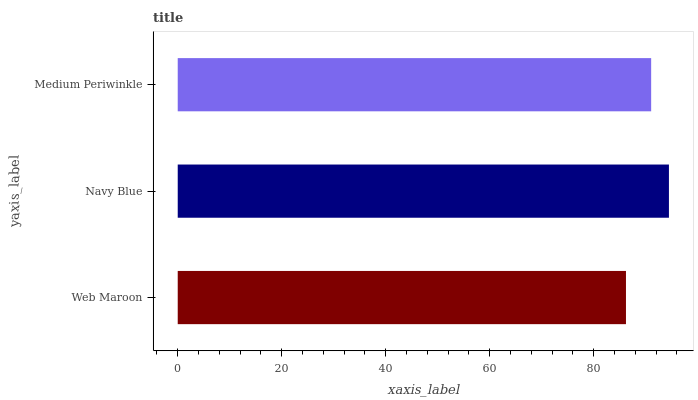Is Web Maroon the minimum?
Answer yes or no. Yes. Is Navy Blue the maximum?
Answer yes or no. Yes. Is Medium Periwinkle the minimum?
Answer yes or no. No. Is Medium Periwinkle the maximum?
Answer yes or no. No. Is Navy Blue greater than Medium Periwinkle?
Answer yes or no. Yes. Is Medium Periwinkle less than Navy Blue?
Answer yes or no. Yes. Is Medium Periwinkle greater than Navy Blue?
Answer yes or no. No. Is Navy Blue less than Medium Periwinkle?
Answer yes or no. No. Is Medium Periwinkle the high median?
Answer yes or no. Yes. Is Medium Periwinkle the low median?
Answer yes or no. Yes. Is Navy Blue the high median?
Answer yes or no. No. Is Navy Blue the low median?
Answer yes or no. No. 